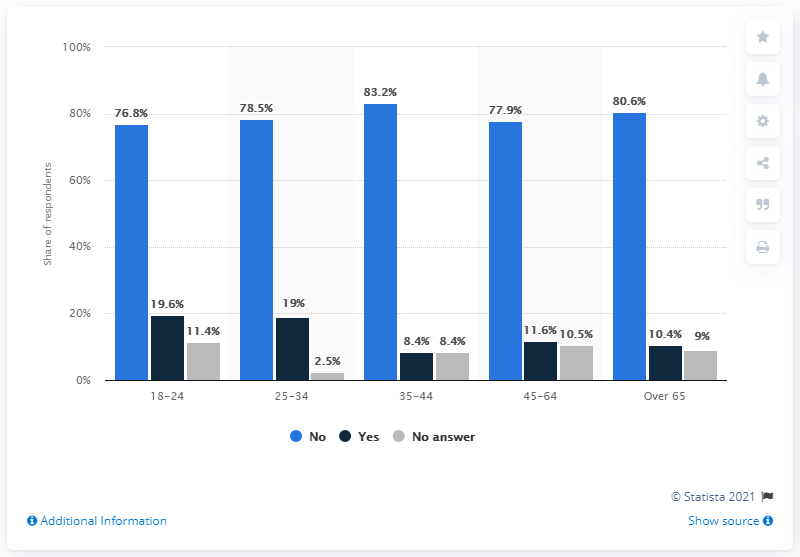Identify some key points in this picture. The average of "Yes" answers for the question in all categories is 13.8. (The average of all dark blue bars is 13.8.) Based on the data provided, 19% of the people in the 25-34 age category responded "yes" to the question. 